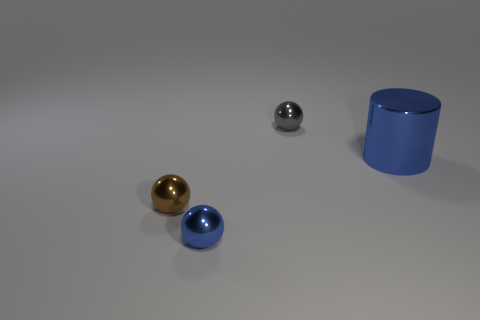Subtract all gray cylinders. Subtract all blue balls. How many cylinders are left? 1 Add 3 small things. How many objects exist? 7 Subtract all balls. How many objects are left? 1 Subtract 0 gray blocks. How many objects are left? 4 Subtract all big blue cylinders. Subtract all metallic cylinders. How many objects are left? 2 Add 4 tiny blue metal objects. How many tiny blue metal objects are left? 5 Add 1 blue things. How many blue things exist? 3 